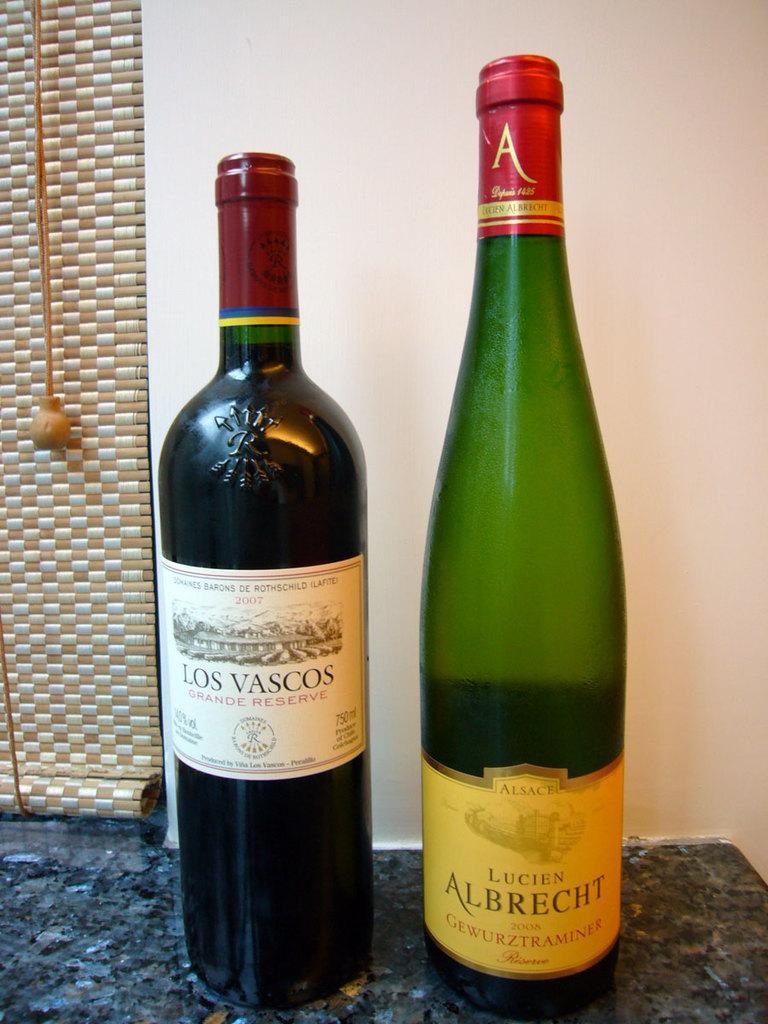Could you give a brief overview of what you see in this image? There are two wine bottles placed on the table. in the background there is a wall and a curtain here. 